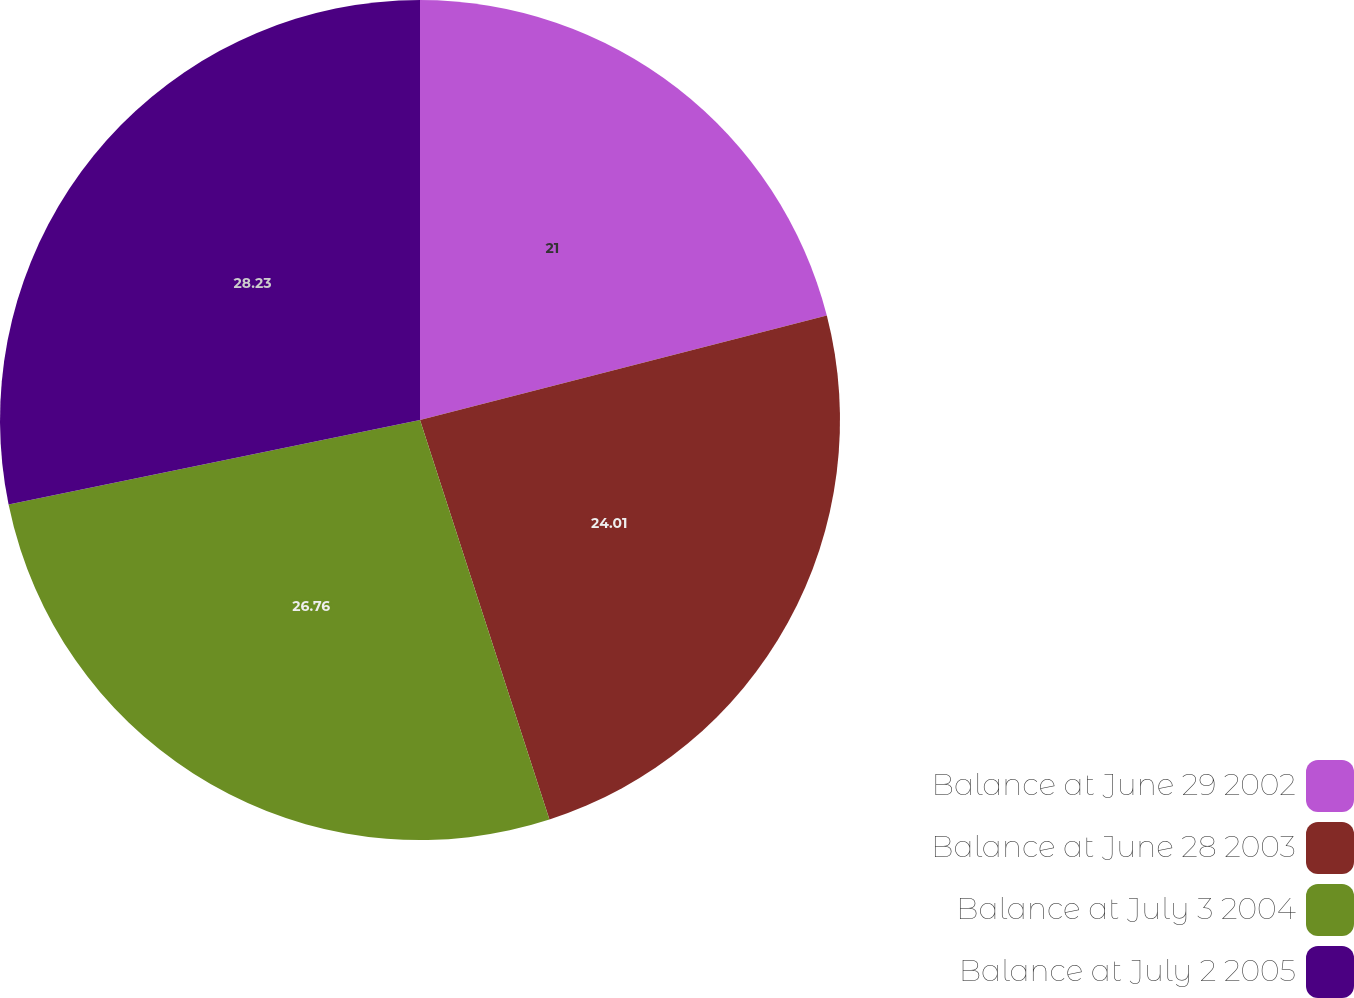Convert chart. <chart><loc_0><loc_0><loc_500><loc_500><pie_chart><fcel>Balance at June 29 2002<fcel>Balance at June 28 2003<fcel>Balance at July 3 2004<fcel>Balance at July 2 2005<nl><fcel>21.0%<fcel>24.01%<fcel>26.76%<fcel>28.22%<nl></chart> 